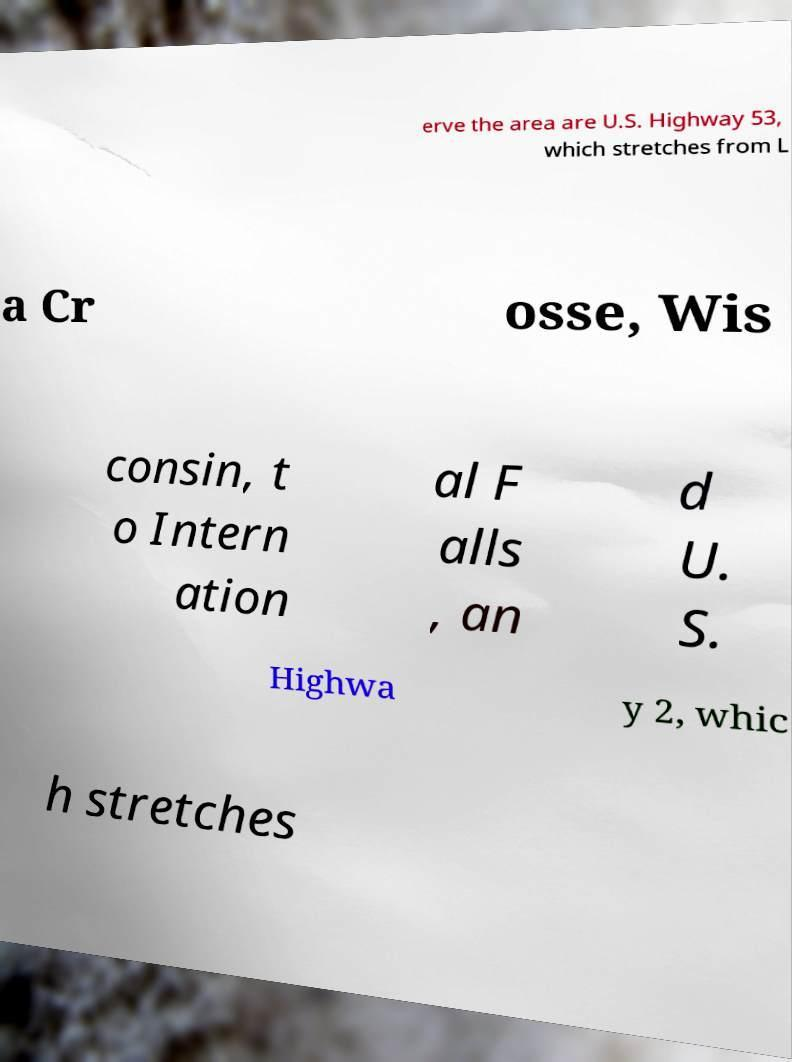What messages or text are displayed in this image? I need them in a readable, typed format. erve the area are U.S. Highway 53, which stretches from L a Cr osse, Wis consin, t o Intern ation al F alls , an d U. S. Highwa y 2, whic h stretches 